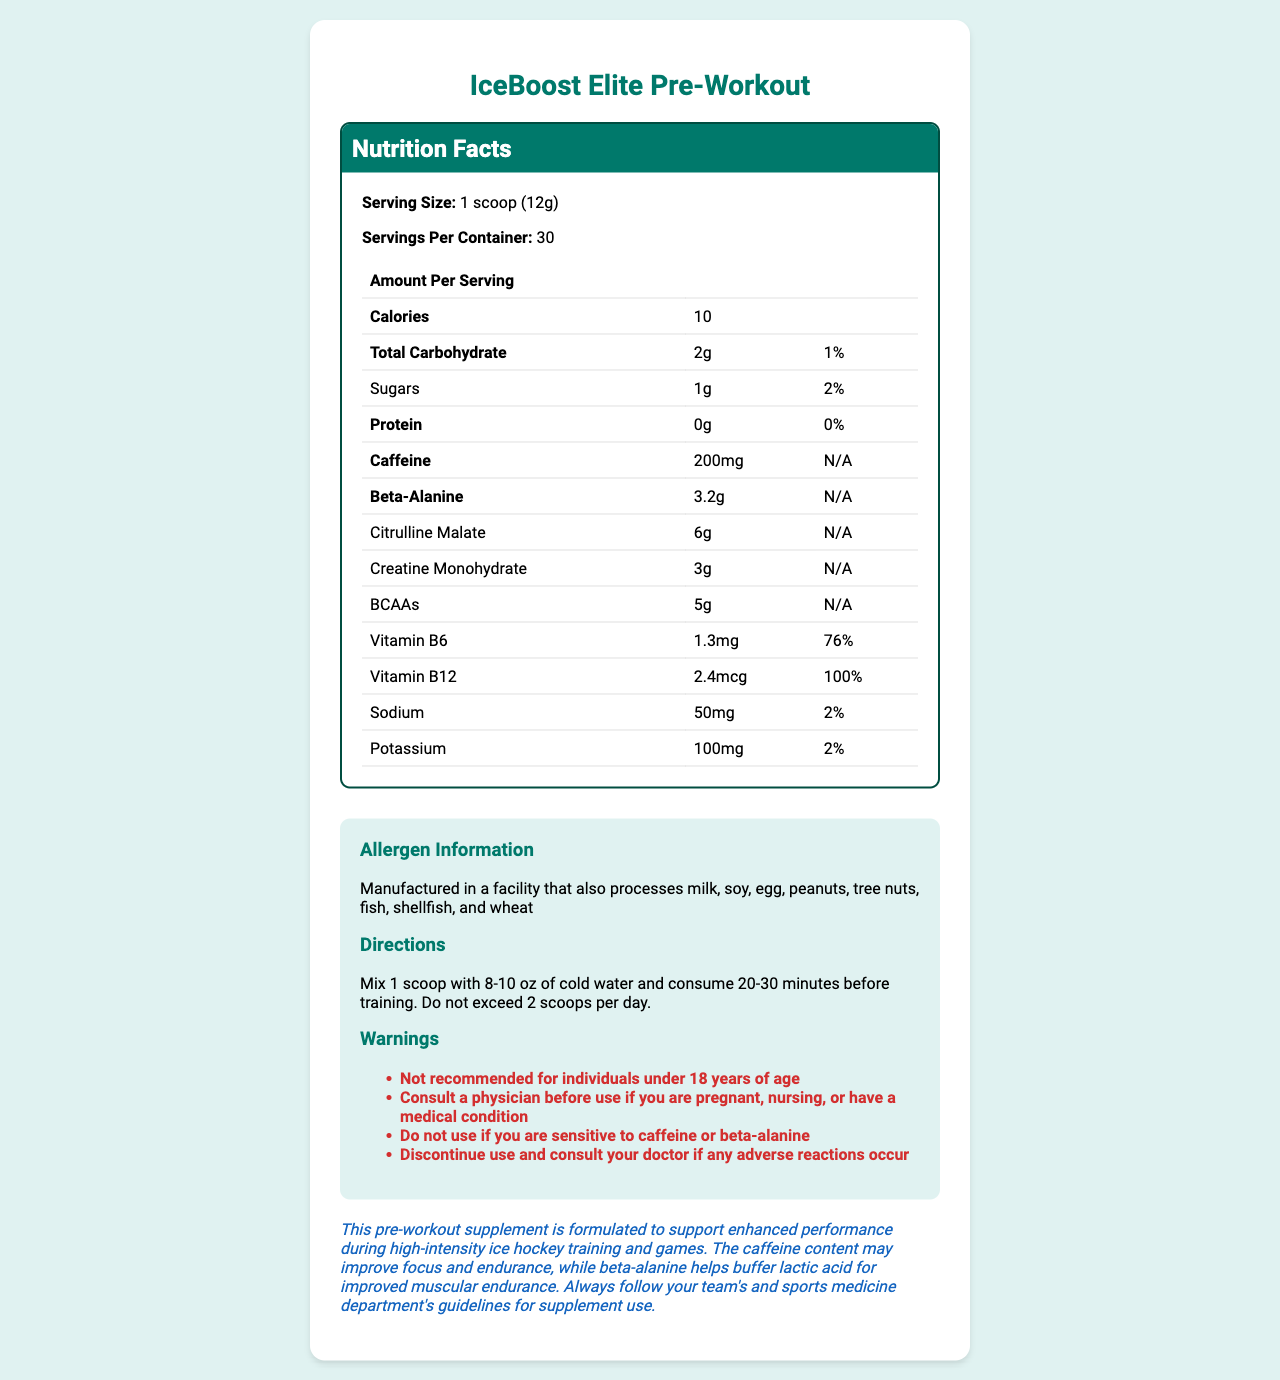what is the serving size of IceBoost Elite Pre-Workout? The serving size is listed directly under "Serving Size" in the Nutrition Facts section.
Answer: 1 scoop (12g) how many calories are in one serving? The calories per serving are listed as 10 in the Nutrition Facts table.
Answer: 10 what is the total carbohydrate content per serving? The total carbohydrate amount is listed in the Nutrition Facts, under the "Total Carbohydrate" row.
Answer: 2g what is the daily value percentage of vitamin B6 per serving? The daily value percentage for vitamin B6 is listed as 76% under the "Vitamin B6" row in the Nutrition Facts.
Answer: 76% how much caffeine does one serving contain? The caffeine content is listed as 200mg in the Nutrition Facts section.
Answer: 200mg which ingredient has the highest amount per serving? A. Creatine Monohydrate B. Citrulline Malate C. Beta-Alanine D. BCAAs Citrulline Malate has the highest amount per serving at 6g, as listed in the Nutrition Facts.
Answer: B. Citrulline Malate what is the daily value percentage for sodium in this supplement? A. 1% B. 2% C. 3% D. 4% The daily value percentage for sodium is listed as 2% under the "Sodium" row in the Nutrition Facts.
Answer: B. 2% is the information provided sufficient to determine if this product is safe for a 16-year-old to use? The warnings section explicitly states, "Not recommended for individuals under 18 years of age."
Answer: No summarize the primary purpose of this pre-workout supplement. The document states that the supplement is formulated for high-intensity ice hockey training, highlighting its key ingredients and their intended effects on performance.
Answer: This pre-workout supplement, IceBoost Elite Pre-Workout, is designed to enhance performance during high-intensity ice hockey training and games. It contains ingredients such as caffeine for focus and endurance, beta-alanine for buffering lactic acid, and other compounds to support muscular endurance and overall performance. how should this pre-workout supplement be consumed? The directions for use provide specific instructions on how to mix and when to consume the supplement.
Answer: Mix 1 scoop with 8-10 oz of cold water and consume 20-30 minutes before training. Do not exceed 2 scoops per day. what are the potential allergens in this product? The allergen information specifies the potential allergens present from the manufacturing facility.
Answer: Manufactured in a facility that also processes milk, soy, egg, peanuts, tree nuts, fish, shellfish, and wheat can the exact sugar content of the supplement be determined? The amount of sugars is listed as 1g per serving along with a daily value percentage of 2%.
Answer: Yes what should you do if you experience adverse reactions? The warning section advises to stop using the product and consult a doctor if any adverse reactions occur.
Answer: Discontinue use and consult your doctor if any adverse reactions occur is the daily value percentage for potassium provided? The daily value percentage for potassium is listed as 2% under the "Potassium" row in the Nutrition Facts section.
Answer: Yes, 2% does the supplement provide any protein per serving? There is 0g of protein per serving indicated in the Nutrition Facts section.
Answer: No how does this supplement support enhanced performance in ice hockey training and games? The athlete note explains how caffeine and beta-alanine can enhance performance.
Answer: The caffeine content may improve focus and endurance, while beta-alanine helps buffer lactic acid for improved muscular endurance. does the document provide the amount of BCAAs per serving? The amount of BCAAs per serving is listed as 5g in the Nutrition Facts section.
Answer: Yes, 5g what would you do if you are sensitive to caffeine or beta-alanine? The warning section advises not to use the supplement if you are sensitive to caffeine or beta-alanine.
Answer: Do not use the supplement are the daily value percentages for creatine monohydrate provided? The daily value percentages are not provided for creatine monohydrate or several other ingredients in the Nutrition Facts section.
Answer: No 